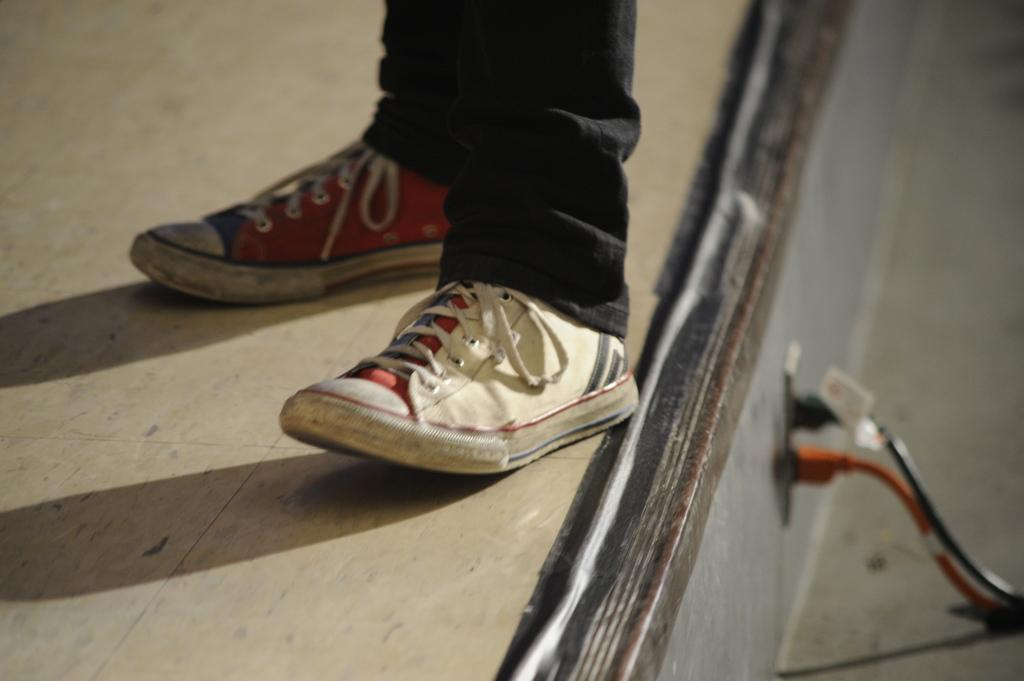What body part is visible in the image? There is a person's leg with shoes in the image. What type of clothing is the person wearing on their leg? The person is wearing black color trousers. What objects can be seen connected to a socket in the image? There are cables visible in the image, and they are attached to a socket. What type of jam is being served in the image? There is no jam present in the image. What class of people are depicted in the image? The image does not depict any specific class of people; it only shows a person's leg with shoes and black trousers. 